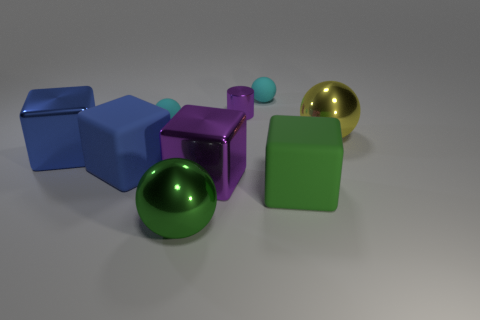Subtract all large green balls. How many balls are left? 3 Subtract all cubes. How many objects are left? 5 Subtract 2 balls. How many balls are left? 2 Add 7 tiny purple things. How many tiny purple things exist? 8 Subtract all yellow balls. How many balls are left? 3 Subtract 0 blue spheres. How many objects are left? 9 Subtract all brown cubes. Subtract all red spheres. How many cubes are left? 4 Subtract all blue cylinders. How many brown balls are left? 0 Subtract all large purple cubes. Subtract all cubes. How many objects are left? 4 Add 3 green shiny balls. How many green shiny balls are left? 4 